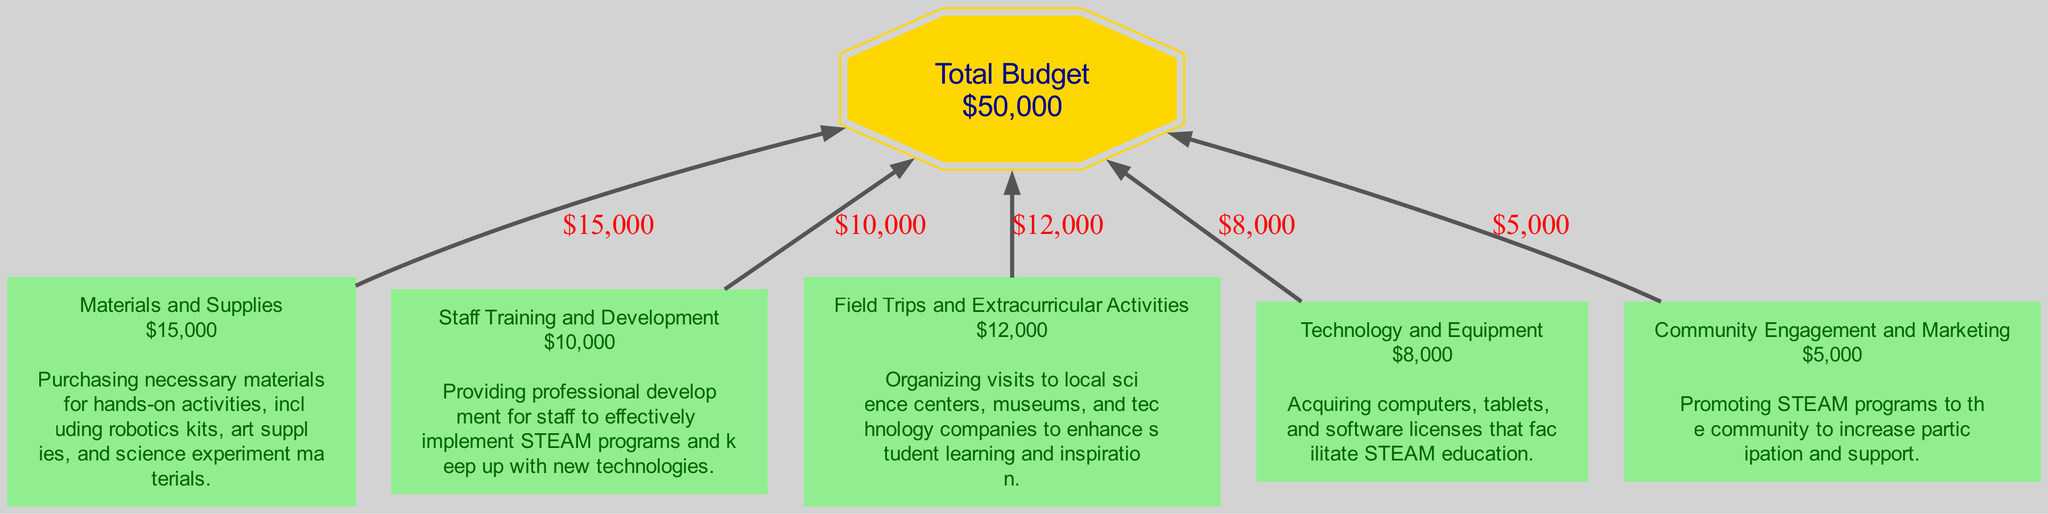What is the total budget for the STEAM program? The total budget node in the diagram states the total amount allocated, which is displayed in the shape of a double octagon. The value shown is 50,000.
Answer: 50,000 How much is allocated to Materials and Supplies? The Materials and Supplies category has a node that shows its specific budget allocation. The amount listed is 15,000.
Answer: 15,000 What is the justification for the Staff Training and Development budget? To find the justification, we refer to the Staff Training and Development node, where the detailed justification is provided. It explains the need for professional development for staff.
Answer: Providing professional development for staff to effectively implement STEAM programs and keep up with new technologies How many expense categories are listed in the diagram? We can count the number of unique categories that are connected to the total budget node. There are five expense categories outlined in the diagram.
Answer: 5 Which expense category has the lowest budget allocation? By inspecting the budget allocations for each category within the nodes, we can identify that Community Engagement and Marketing, with a budget allocation of 5,000, is the lowest.
Answer: Community Engagement and Marketing What is the total budget allocation for Field Trips and Extracurricular Activities and Technology and Equipment combined? First, we find the budget for Field Trips and Extracurricular Activities, which is 12,000, and for Technology and Equipment, which is 8,000. Adding these together results in 20,000.
Answer: 20,000 Which category has a budget allocation of 10,000? By checking the nodes for each expense category, we can pinpoint that Staff Training and Development is the only category with an allocation of 10,000.
Answer: Staff Training and Development How does the budget for Materials and Supplies compare with the budget for Technology and Equipment? We look at both categories, where Materials and Supplies has 15,000 and Technology and Equipment has 8,000. Since 15,000 is greater than 8,000, we conclude that Materials and Supplies has a larger allocation.
Answer: Materials and Supplies What connects all the expense categories to the total budget? The diagram represents connections with arrows indicating the flow of budget allocation from each expense category to the total budget node. These arrows signify that each budget is part of the total budget amount.
Answer: Arrows 